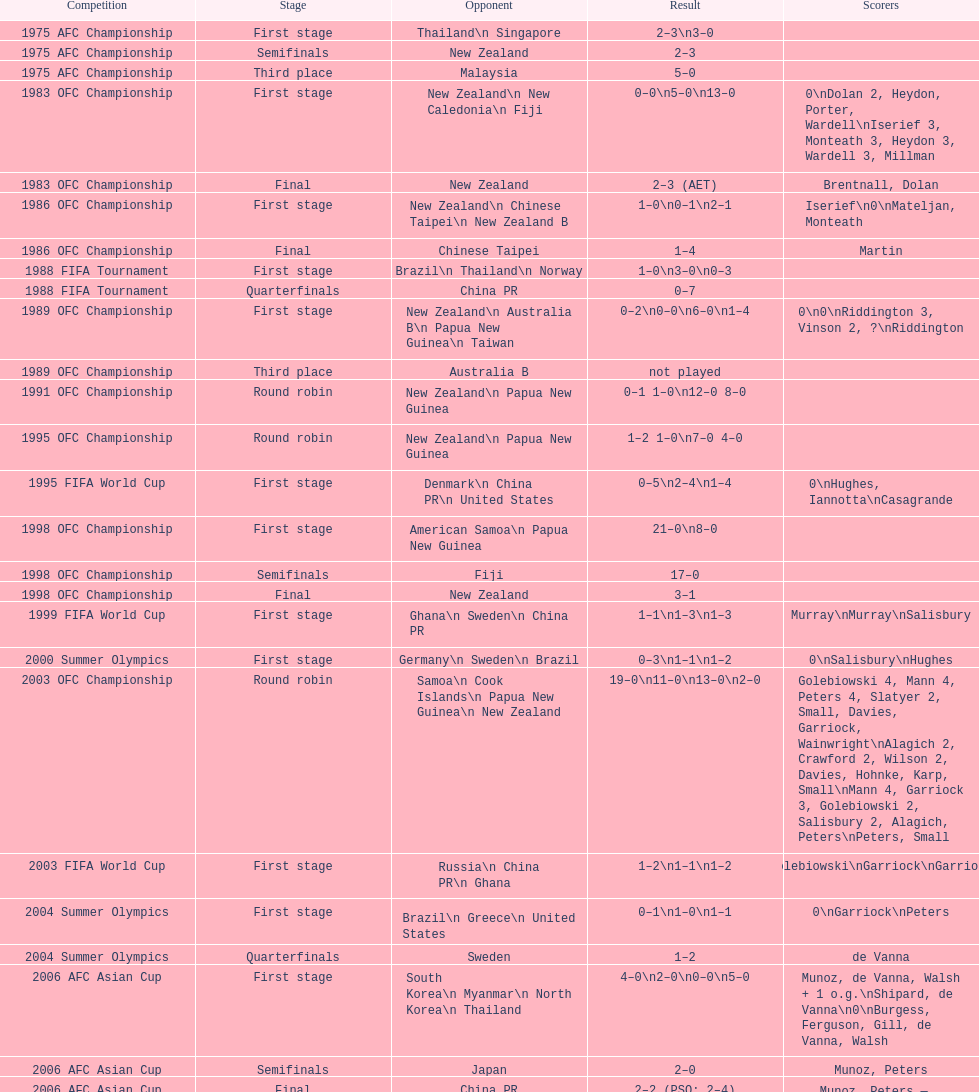Who was this team's next opponent after facing new zealand in the first stage of the 1986 ofc championship? Chinese Taipei. Could you parse the entire table? {'header': ['Competition', 'Stage', 'Opponent', 'Result', 'Scorers'], 'rows': [['1975 AFC Championship', 'First stage', 'Thailand\\n\xa0Singapore', '2–3\\n3–0', ''], ['1975 AFC Championship', 'Semifinals', 'New Zealand', '2–3', ''], ['1975 AFC Championship', 'Third place', 'Malaysia', '5–0', ''], ['1983 OFC Championship', 'First stage', 'New Zealand\\n\xa0New Caledonia\\n\xa0Fiji', '0–0\\n5–0\\n13–0', '0\\nDolan 2, Heydon, Porter, Wardell\\nIserief 3, Monteath 3, Heydon 3, Wardell 3, Millman'], ['1983 OFC Championship', 'Final', 'New Zealand', '2–3 (AET)', 'Brentnall, Dolan'], ['1986 OFC Championship', 'First stage', 'New Zealand\\n\xa0Chinese Taipei\\n New Zealand B', '1–0\\n0–1\\n2–1', 'Iserief\\n0\\nMateljan, Monteath'], ['1986 OFC Championship', 'Final', 'Chinese Taipei', '1–4', 'Martin'], ['1988 FIFA Tournament', 'First stage', 'Brazil\\n\xa0Thailand\\n\xa0Norway', '1–0\\n3–0\\n0–3', ''], ['1988 FIFA Tournament', 'Quarterfinals', 'China PR', '0–7', ''], ['1989 OFC Championship', 'First stage', 'New Zealand\\n Australia B\\n\xa0Papua New Guinea\\n\xa0Taiwan', '0–2\\n0–0\\n6–0\\n1–4', '0\\n0\\nRiddington 3, Vinson 2,\xa0?\\nRiddington'], ['1989 OFC Championship', 'Third place', 'Australia B', 'not played', ''], ['1991 OFC Championship', 'Round robin', 'New Zealand\\n\xa0Papua New Guinea', '0–1 1–0\\n12–0 8–0', ''], ['1995 OFC Championship', 'Round robin', 'New Zealand\\n\xa0Papua New Guinea', '1–2 1–0\\n7–0 4–0', ''], ['1995 FIFA World Cup', 'First stage', 'Denmark\\n\xa0China PR\\n\xa0United States', '0–5\\n2–4\\n1–4', '0\\nHughes, Iannotta\\nCasagrande'], ['1998 OFC Championship', 'First stage', 'American Samoa\\n\xa0Papua New Guinea', '21–0\\n8–0', ''], ['1998 OFC Championship', 'Semifinals', 'Fiji', '17–0', ''], ['1998 OFC Championship', 'Final', 'New Zealand', '3–1', ''], ['1999 FIFA World Cup', 'First stage', 'Ghana\\n\xa0Sweden\\n\xa0China PR', '1–1\\n1–3\\n1–3', 'Murray\\nMurray\\nSalisbury'], ['2000 Summer Olympics', 'First stage', 'Germany\\n\xa0Sweden\\n\xa0Brazil', '0–3\\n1–1\\n1–2', '0\\nSalisbury\\nHughes'], ['2003 OFC Championship', 'Round robin', 'Samoa\\n\xa0Cook Islands\\n\xa0Papua New Guinea\\n\xa0New Zealand', '19–0\\n11–0\\n13–0\\n2–0', 'Golebiowski 4, Mann 4, Peters 4, Slatyer 2, Small, Davies, Garriock, Wainwright\\nAlagich 2, Crawford 2, Wilson 2, Davies, Hohnke, Karp, Small\\nMann 4, Garriock 3, Golebiowski 2, Salisbury 2, Alagich, Peters\\nPeters, Small'], ['2003 FIFA World Cup', 'First stage', 'Russia\\n\xa0China PR\\n\xa0Ghana', '1–2\\n1–1\\n1–2', 'Golebiowski\\nGarriock\\nGarriock'], ['2004 Summer Olympics', 'First stage', 'Brazil\\n\xa0Greece\\n\xa0United States', '0–1\\n1–0\\n1–1', '0\\nGarriock\\nPeters'], ['2004 Summer Olympics', 'Quarterfinals', 'Sweden', '1–2', 'de Vanna'], ['2006 AFC Asian Cup', 'First stage', 'South Korea\\n\xa0Myanmar\\n\xa0North Korea\\n\xa0Thailand', '4–0\\n2–0\\n0–0\\n5–0', 'Munoz, de Vanna, Walsh + 1 o.g.\\nShipard, de Vanna\\n0\\nBurgess, Ferguson, Gill, de Vanna, Walsh'], ['2006 AFC Asian Cup', 'Semifinals', 'Japan', '2–0', 'Munoz, Peters'], ['2006 AFC Asian Cup', 'Final', 'China PR', '2–2 (PSO: 2–4)', 'Munoz, Peters — Shipard, Ferguson McCallum, Peters'], ['2007 FIFA World Cup', 'First stage', 'Ghana\\n\xa0Norway\\n\xa0Canada', '4–1\\n1–1\\n2–2', 'de Vanna 2, Garriock, Walsh\\nde Vanna\\nMcCallum, Salisbury'], ['2007 FIFA World Cup', 'Quarterfinals', 'Brazil', '2–3', 'Colthorpe, de Vanna'], ['2008 AFC Asian Cup', 'First stage', 'Chinese Taipei\\n\xa0South Korea\\n\xa0Japan', '4–0\\n2–0', 'Garriock 2, Tristram, de Vanna\\nPerry, de Vanna\\nPolkinghorne'], ['2008 AFC Asian Cup', 'Semifinals', 'North Korea', '0–3', ''], ['2008 AFC Asian Cup', 'Third place', 'Japan', '0–3', ''], ['2010 AFC Asian Cup', 'First stage', 'Vietnam\\n\xa0South Korea\\n\xa0China PR', '2–0\\n3–1\\n0–1', 'Khamis, Ledbrook\\nCarroll, Kerr, de Vanna\\n0'], ['2010 AFC Asian Cup', 'Semifinals', 'Japan', '1–0', 'Gill'], ['2010 AFC Asian Cup', 'Final', 'North Korea', '1–1 (PSO: 5–4)', 'Kerr — PSO: Shipard, Ledbrook, Gill, Garriock, Simon'], ['2011 FIFA World Cup', 'First stage', 'Brazil\\n\xa0Equatorial Guinea\\n\xa0Norway', '0–1\\n3–2\\n2–1', '0\\nvan Egmond, Khamis, de Vanna\\nSimon 2'], ['2011 FIFA World Cup', 'Quarterfinals', 'Sweden', '1–3', 'Perry'], ['2012 Summer Olympics\\nAFC qualification', 'Final round', 'North Korea\\n\xa0Thailand\\n\xa0Japan\\n\xa0China PR\\n\xa0South Korea', '0–1\\n5–1\\n0–1\\n1–0\\n2–1', '0\\nHeyman 2, Butt, van Egmond, Simon\\n0\\nvan Egmond\\nButt, de Vanna'], ['2014 AFC Asian Cup', 'First stage', 'Japan\\n\xa0Jordan\\n\xa0Vietnam', 'TBD\\nTBD\\nTBD', '']]} 